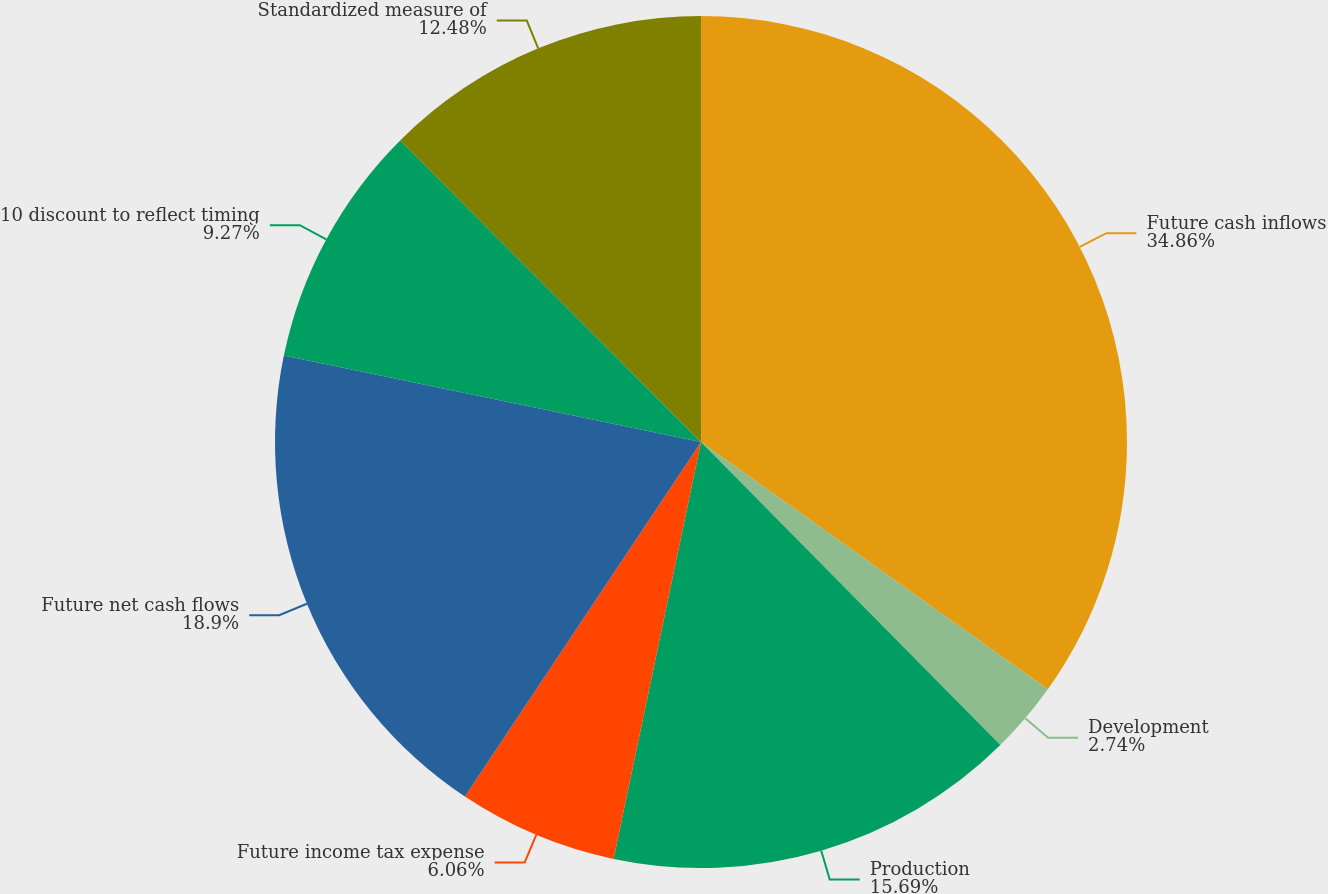Convert chart. <chart><loc_0><loc_0><loc_500><loc_500><pie_chart><fcel>Future cash inflows<fcel>Development<fcel>Production<fcel>Future income tax expense<fcel>Future net cash flows<fcel>10 discount to reflect timing<fcel>Standardized measure of<nl><fcel>34.86%<fcel>2.74%<fcel>15.69%<fcel>6.06%<fcel>18.9%<fcel>9.27%<fcel>12.48%<nl></chart> 